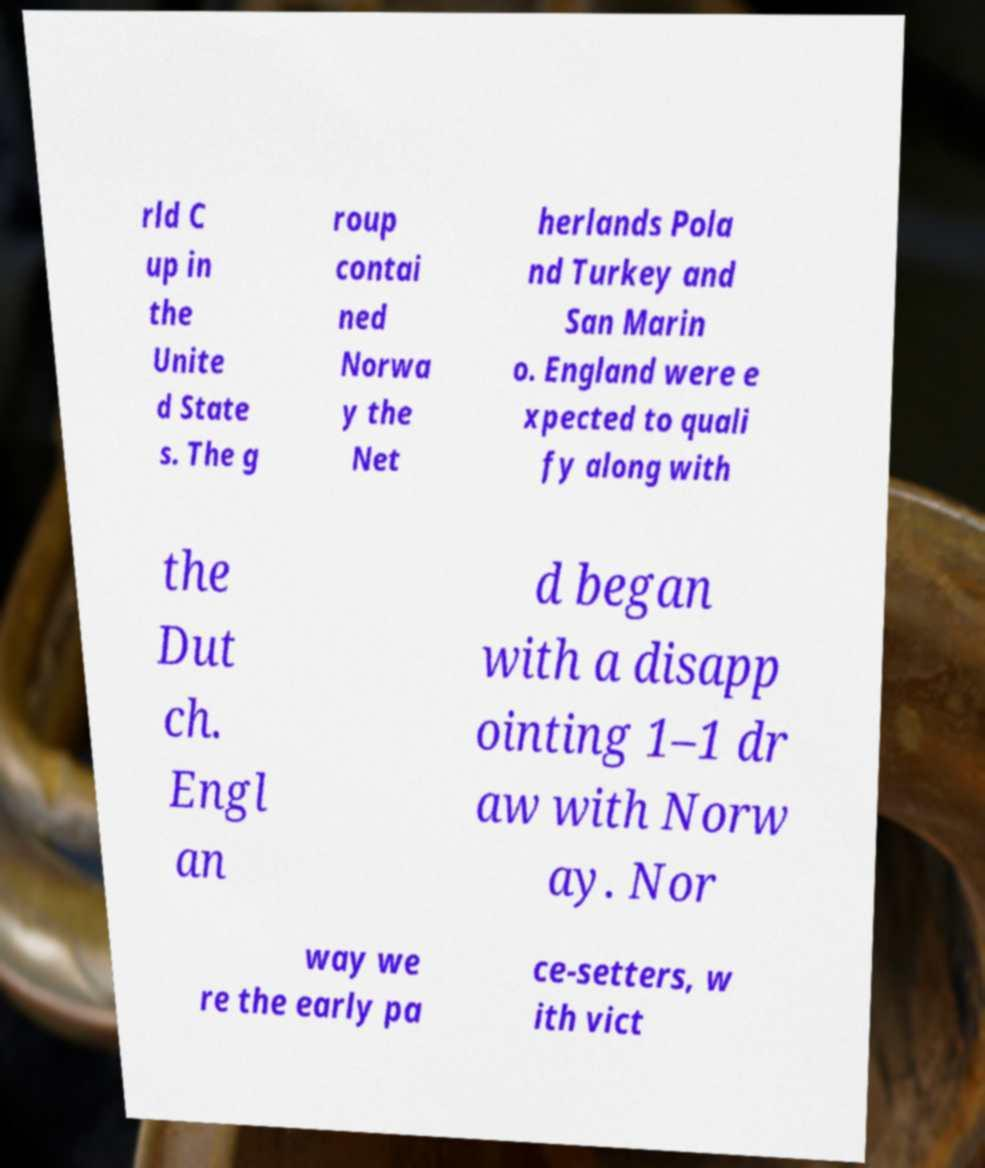There's text embedded in this image that I need extracted. Can you transcribe it verbatim? rld C up in the Unite d State s. The g roup contai ned Norwa y the Net herlands Pola nd Turkey and San Marin o. England were e xpected to quali fy along with the Dut ch. Engl an d began with a disapp ointing 1–1 dr aw with Norw ay. Nor way we re the early pa ce-setters, w ith vict 